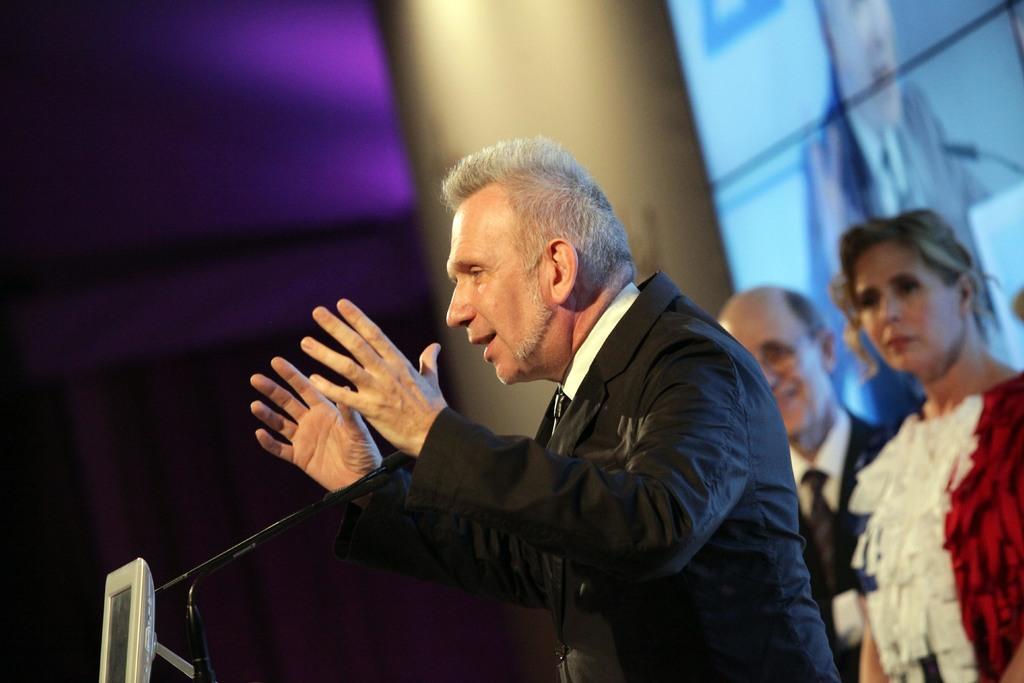Can you describe this image briefly? In the image in the center, we can see one person standing. In front of him, we can see one microphone. In the background there is a screen and two persons are standing. 